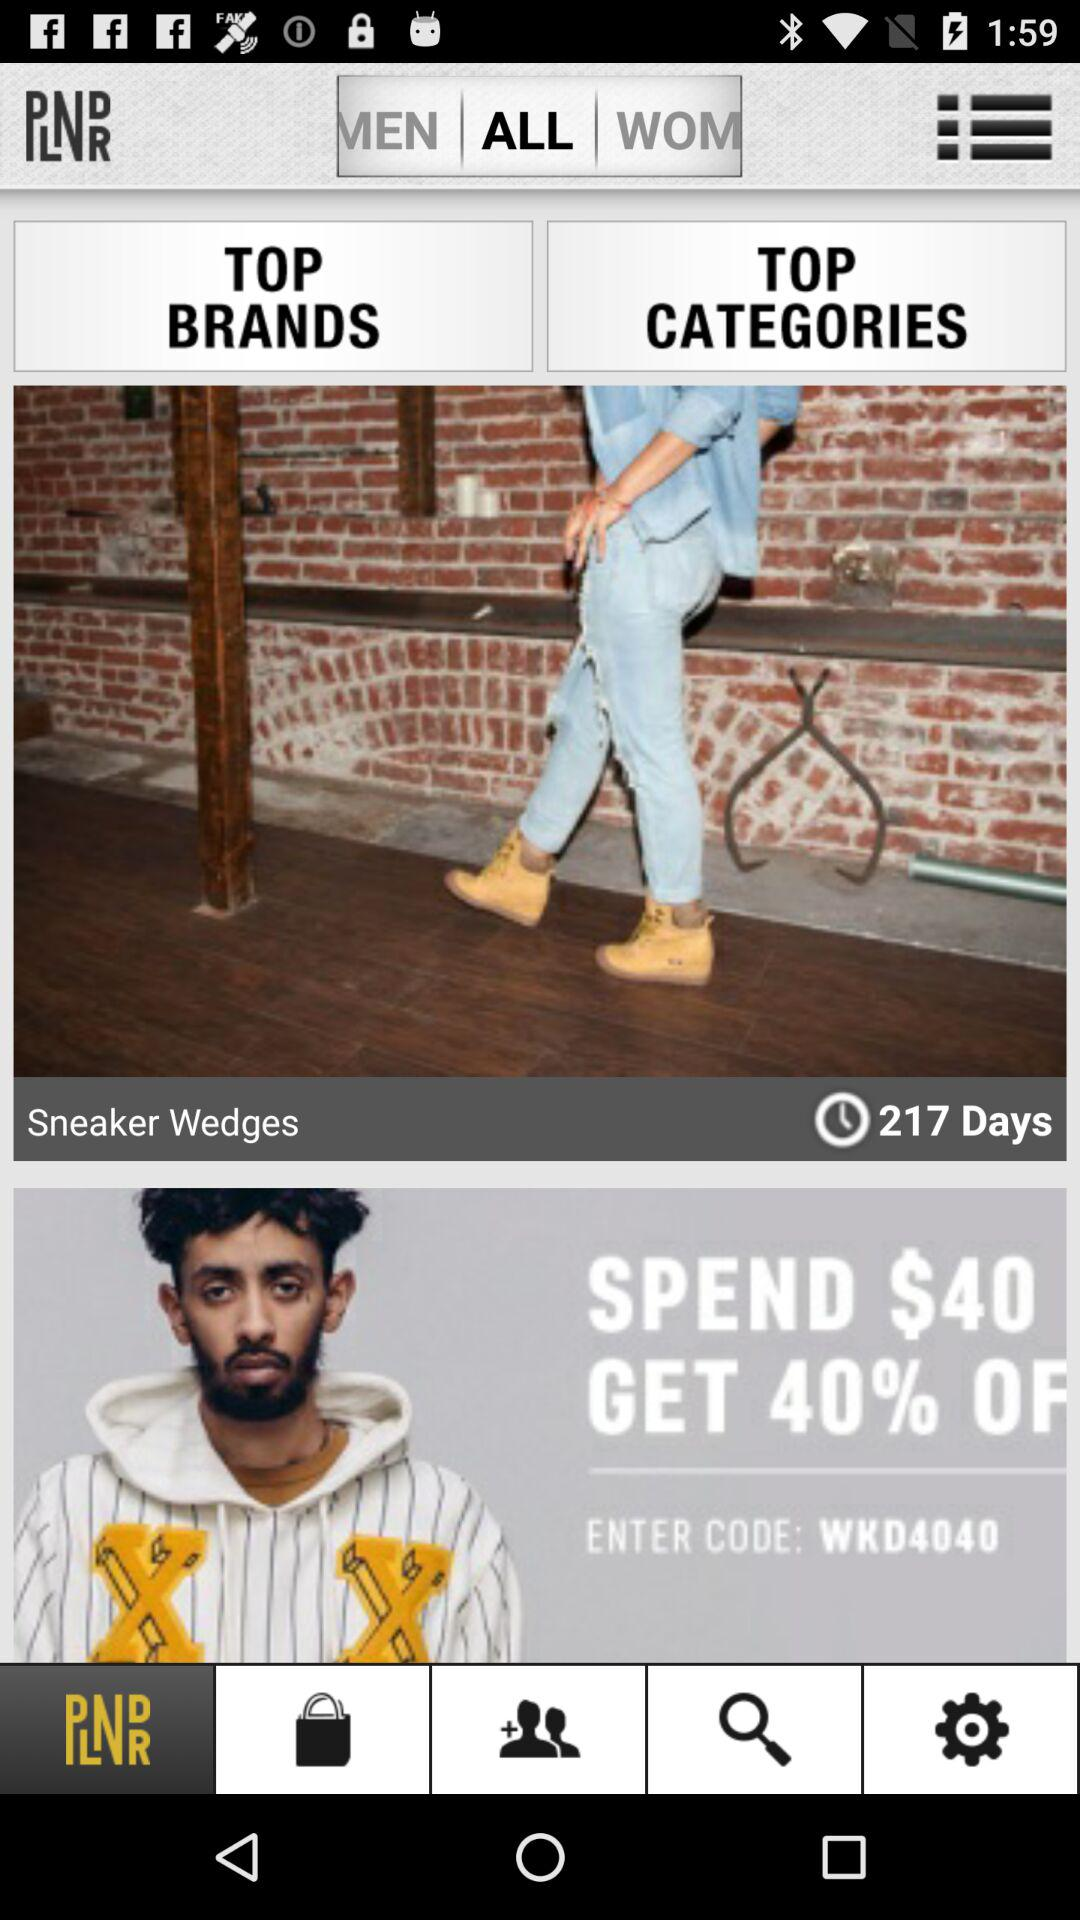How much is the discount for spending $40?
Answer the question using a single word or phrase. 40% 